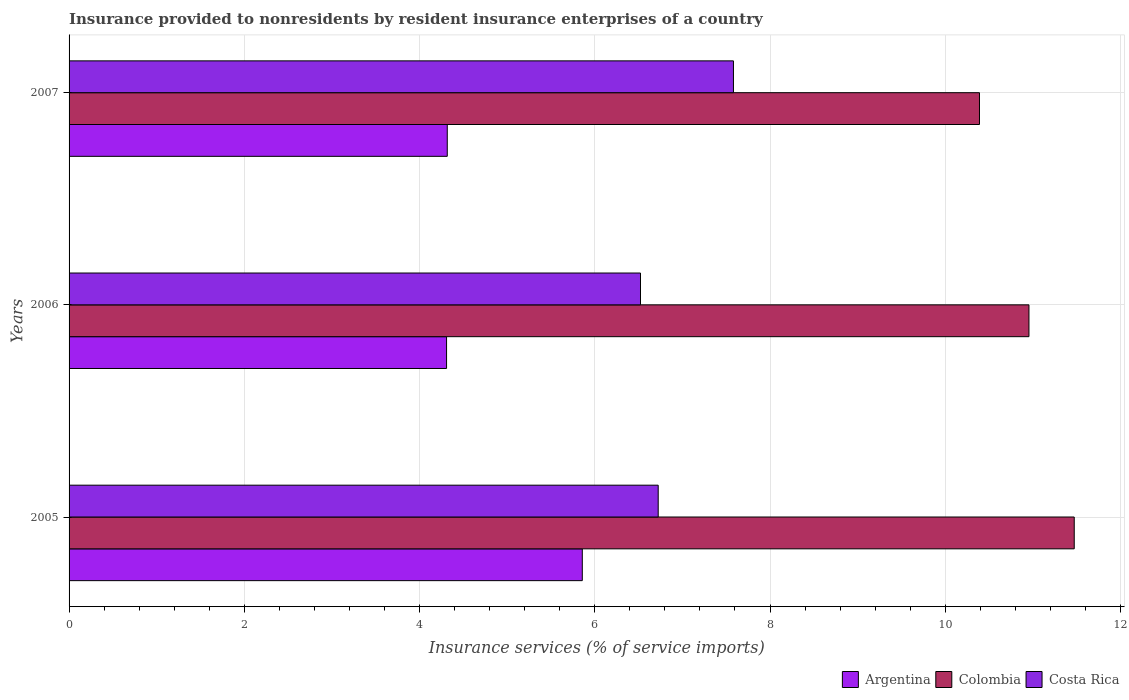How many different coloured bars are there?
Give a very brief answer. 3. How many groups of bars are there?
Keep it short and to the point. 3. Are the number of bars per tick equal to the number of legend labels?
Your response must be concise. Yes. What is the label of the 1st group of bars from the top?
Provide a short and direct response. 2007. In how many cases, is the number of bars for a given year not equal to the number of legend labels?
Your answer should be very brief. 0. What is the insurance provided to nonresidents in Colombia in 2006?
Offer a very short reply. 10.96. Across all years, what is the maximum insurance provided to nonresidents in Costa Rica?
Ensure brevity in your answer.  7.58. Across all years, what is the minimum insurance provided to nonresidents in Argentina?
Offer a terse response. 4.31. In which year was the insurance provided to nonresidents in Colombia minimum?
Offer a very short reply. 2007. What is the total insurance provided to nonresidents in Costa Rica in the graph?
Your response must be concise. 20.83. What is the difference between the insurance provided to nonresidents in Colombia in 2006 and that in 2007?
Offer a terse response. 0.56. What is the difference between the insurance provided to nonresidents in Colombia in 2006 and the insurance provided to nonresidents in Argentina in 2007?
Give a very brief answer. 6.64. What is the average insurance provided to nonresidents in Colombia per year?
Your response must be concise. 10.94. In the year 2005, what is the difference between the insurance provided to nonresidents in Argentina and insurance provided to nonresidents in Costa Rica?
Keep it short and to the point. -0.87. What is the ratio of the insurance provided to nonresidents in Argentina in 2006 to that in 2007?
Your response must be concise. 1. Is the insurance provided to nonresidents in Colombia in 2005 less than that in 2006?
Ensure brevity in your answer.  No. Is the difference between the insurance provided to nonresidents in Argentina in 2005 and 2007 greater than the difference between the insurance provided to nonresidents in Costa Rica in 2005 and 2007?
Your answer should be compact. Yes. What is the difference between the highest and the second highest insurance provided to nonresidents in Costa Rica?
Keep it short and to the point. 0.86. What is the difference between the highest and the lowest insurance provided to nonresidents in Costa Rica?
Your answer should be compact. 1.06. In how many years, is the insurance provided to nonresidents in Costa Rica greater than the average insurance provided to nonresidents in Costa Rica taken over all years?
Give a very brief answer. 1. Is it the case that in every year, the sum of the insurance provided to nonresidents in Argentina and insurance provided to nonresidents in Costa Rica is greater than the insurance provided to nonresidents in Colombia?
Offer a terse response. No. Are all the bars in the graph horizontal?
Keep it short and to the point. Yes. Are the values on the major ticks of X-axis written in scientific E-notation?
Your response must be concise. No. Does the graph contain grids?
Keep it short and to the point. Yes. Where does the legend appear in the graph?
Your response must be concise. Bottom right. What is the title of the graph?
Make the answer very short. Insurance provided to nonresidents by resident insurance enterprises of a country. What is the label or title of the X-axis?
Make the answer very short. Insurance services (% of service imports). What is the label or title of the Y-axis?
Your answer should be very brief. Years. What is the Insurance services (% of service imports) in Argentina in 2005?
Ensure brevity in your answer.  5.86. What is the Insurance services (% of service imports) of Colombia in 2005?
Your answer should be very brief. 11.47. What is the Insurance services (% of service imports) in Costa Rica in 2005?
Offer a terse response. 6.72. What is the Insurance services (% of service imports) in Argentina in 2006?
Make the answer very short. 4.31. What is the Insurance services (% of service imports) of Colombia in 2006?
Offer a very short reply. 10.96. What is the Insurance services (% of service imports) in Costa Rica in 2006?
Make the answer very short. 6.52. What is the Insurance services (% of service imports) of Argentina in 2007?
Provide a short and direct response. 4.32. What is the Insurance services (% of service imports) of Colombia in 2007?
Provide a succinct answer. 10.39. What is the Insurance services (% of service imports) of Costa Rica in 2007?
Your answer should be very brief. 7.58. Across all years, what is the maximum Insurance services (% of service imports) of Argentina?
Ensure brevity in your answer.  5.86. Across all years, what is the maximum Insurance services (% of service imports) in Colombia?
Provide a short and direct response. 11.47. Across all years, what is the maximum Insurance services (% of service imports) in Costa Rica?
Offer a very short reply. 7.58. Across all years, what is the minimum Insurance services (% of service imports) of Argentina?
Your response must be concise. 4.31. Across all years, what is the minimum Insurance services (% of service imports) of Colombia?
Your answer should be very brief. 10.39. Across all years, what is the minimum Insurance services (% of service imports) of Costa Rica?
Offer a very short reply. 6.52. What is the total Insurance services (% of service imports) of Argentina in the graph?
Your response must be concise. 14.48. What is the total Insurance services (% of service imports) in Colombia in the graph?
Make the answer very short. 32.82. What is the total Insurance services (% of service imports) in Costa Rica in the graph?
Keep it short and to the point. 20.83. What is the difference between the Insurance services (% of service imports) in Argentina in 2005 and that in 2006?
Keep it short and to the point. 1.55. What is the difference between the Insurance services (% of service imports) of Colombia in 2005 and that in 2006?
Offer a terse response. 0.52. What is the difference between the Insurance services (% of service imports) of Costa Rica in 2005 and that in 2006?
Ensure brevity in your answer.  0.2. What is the difference between the Insurance services (% of service imports) of Argentina in 2005 and that in 2007?
Provide a succinct answer. 1.54. What is the difference between the Insurance services (% of service imports) in Colombia in 2005 and that in 2007?
Give a very brief answer. 1.08. What is the difference between the Insurance services (% of service imports) of Costa Rica in 2005 and that in 2007?
Your answer should be compact. -0.86. What is the difference between the Insurance services (% of service imports) in Argentina in 2006 and that in 2007?
Offer a terse response. -0.01. What is the difference between the Insurance services (% of service imports) of Colombia in 2006 and that in 2007?
Your response must be concise. 0.56. What is the difference between the Insurance services (% of service imports) of Costa Rica in 2006 and that in 2007?
Your response must be concise. -1.06. What is the difference between the Insurance services (% of service imports) of Argentina in 2005 and the Insurance services (% of service imports) of Colombia in 2006?
Ensure brevity in your answer.  -5.1. What is the difference between the Insurance services (% of service imports) in Argentina in 2005 and the Insurance services (% of service imports) in Costa Rica in 2006?
Provide a succinct answer. -0.66. What is the difference between the Insurance services (% of service imports) of Colombia in 2005 and the Insurance services (% of service imports) of Costa Rica in 2006?
Keep it short and to the point. 4.95. What is the difference between the Insurance services (% of service imports) of Argentina in 2005 and the Insurance services (% of service imports) of Colombia in 2007?
Offer a very short reply. -4.53. What is the difference between the Insurance services (% of service imports) in Argentina in 2005 and the Insurance services (% of service imports) in Costa Rica in 2007?
Your response must be concise. -1.73. What is the difference between the Insurance services (% of service imports) in Colombia in 2005 and the Insurance services (% of service imports) in Costa Rica in 2007?
Give a very brief answer. 3.89. What is the difference between the Insurance services (% of service imports) in Argentina in 2006 and the Insurance services (% of service imports) in Colombia in 2007?
Provide a succinct answer. -6.08. What is the difference between the Insurance services (% of service imports) of Argentina in 2006 and the Insurance services (% of service imports) of Costa Rica in 2007?
Ensure brevity in your answer.  -3.27. What is the difference between the Insurance services (% of service imports) of Colombia in 2006 and the Insurance services (% of service imports) of Costa Rica in 2007?
Provide a succinct answer. 3.37. What is the average Insurance services (% of service imports) in Argentina per year?
Offer a very short reply. 4.83. What is the average Insurance services (% of service imports) of Colombia per year?
Ensure brevity in your answer.  10.94. What is the average Insurance services (% of service imports) in Costa Rica per year?
Make the answer very short. 6.94. In the year 2005, what is the difference between the Insurance services (% of service imports) in Argentina and Insurance services (% of service imports) in Colombia?
Offer a terse response. -5.61. In the year 2005, what is the difference between the Insurance services (% of service imports) of Argentina and Insurance services (% of service imports) of Costa Rica?
Give a very brief answer. -0.87. In the year 2005, what is the difference between the Insurance services (% of service imports) of Colombia and Insurance services (% of service imports) of Costa Rica?
Your response must be concise. 4.75. In the year 2006, what is the difference between the Insurance services (% of service imports) in Argentina and Insurance services (% of service imports) in Colombia?
Your answer should be compact. -6.65. In the year 2006, what is the difference between the Insurance services (% of service imports) in Argentina and Insurance services (% of service imports) in Costa Rica?
Give a very brief answer. -2.21. In the year 2006, what is the difference between the Insurance services (% of service imports) in Colombia and Insurance services (% of service imports) in Costa Rica?
Offer a terse response. 4.43. In the year 2007, what is the difference between the Insurance services (% of service imports) in Argentina and Insurance services (% of service imports) in Colombia?
Your answer should be compact. -6.07. In the year 2007, what is the difference between the Insurance services (% of service imports) in Argentina and Insurance services (% of service imports) in Costa Rica?
Your answer should be very brief. -3.27. In the year 2007, what is the difference between the Insurance services (% of service imports) of Colombia and Insurance services (% of service imports) of Costa Rica?
Provide a short and direct response. 2.81. What is the ratio of the Insurance services (% of service imports) in Argentina in 2005 to that in 2006?
Your answer should be very brief. 1.36. What is the ratio of the Insurance services (% of service imports) in Colombia in 2005 to that in 2006?
Ensure brevity in your answer.  1.05. What is the ratio of the Insurance services (% of service imports) of Costa Rica in 2005 to that in 2006?
Keep it short and to the point. 1.03. What is the ratio of the Insurance services (% of service imports) of Argentina in 2005 to that in 2007?
Offer a terse response. 1.36. What is the ratio of the Insurance services (% of service imports) in Colombia in 2005 to that in 2007?
Your response must be concise. 1.1. What is the ratio of the Insurance services (% of service imports) of Costa Rica in 2005 to that in 2007?
Offer a terse response. 0.89. What is the ratio of the Insurance services (% of service imports) of Argentina in 2006 to that in 2007?
Provide a succinct answer. 1. What is the ratio of the Insurance services (% of service imports) in Colombia in 2006 to that in 2007?
Offer a very short reply. 1.05. What is the ratio of the Insurance services (% of service imports) in Costa Rica in 2006 to that in 2007?
Offer a very short reply. 0.86. What is the difference between the highest and the second highest Insurance services (% of service imports) of Argentina?
Offer a terse response. 1.54. What is the difference between the highest and the second highest Insurance services (% of service imports) of Colombia?
Offer a very short reply. 0.52. What is the difference between the highest and the second highest Insurance services (% of service imports) of Costa Rica?
Keep it short and to the point. 0.86. What is the difference between the highest and the lowest Insurance services (% of service imports) of Argentina?
Offer a very short reply. 1.55. What is the difference between the highest and the lowest Insurance services (% of service imports) in Colombia?
Provide a succinct answer. 1.08. What is the difference between the highest and the lowest Insurance services (% of service imports) in Costa Rica?
Your response must be concise. 1.06. 